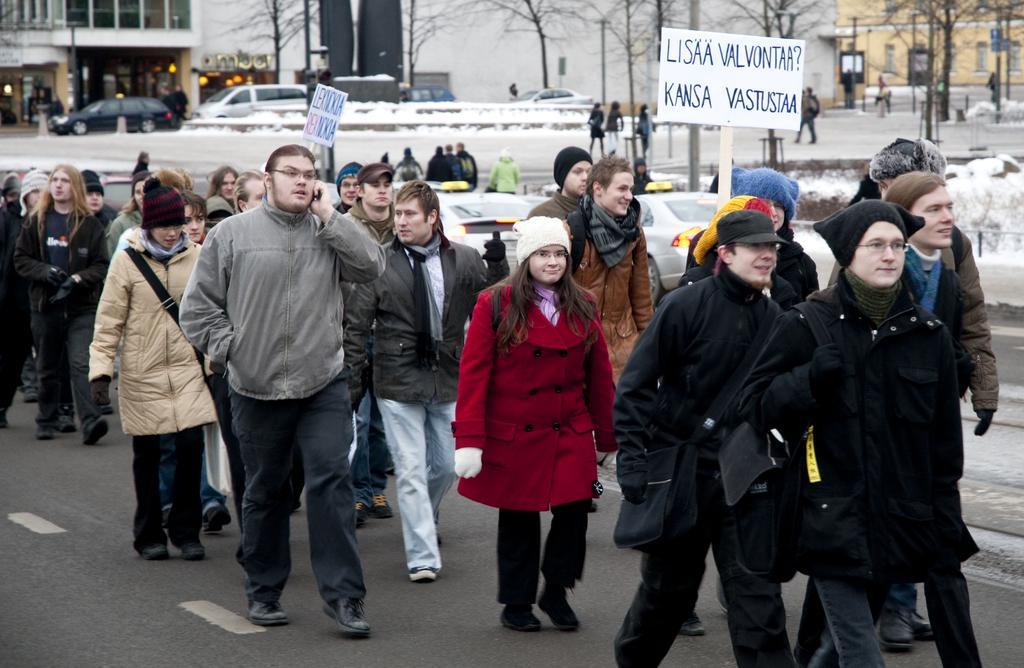In one or two sentences, can you explain what this image depicts? In this image there are few people on the road in some of them are holding placards, there are few vehicles, electric poles, buildings, trees and snow on the ground. 